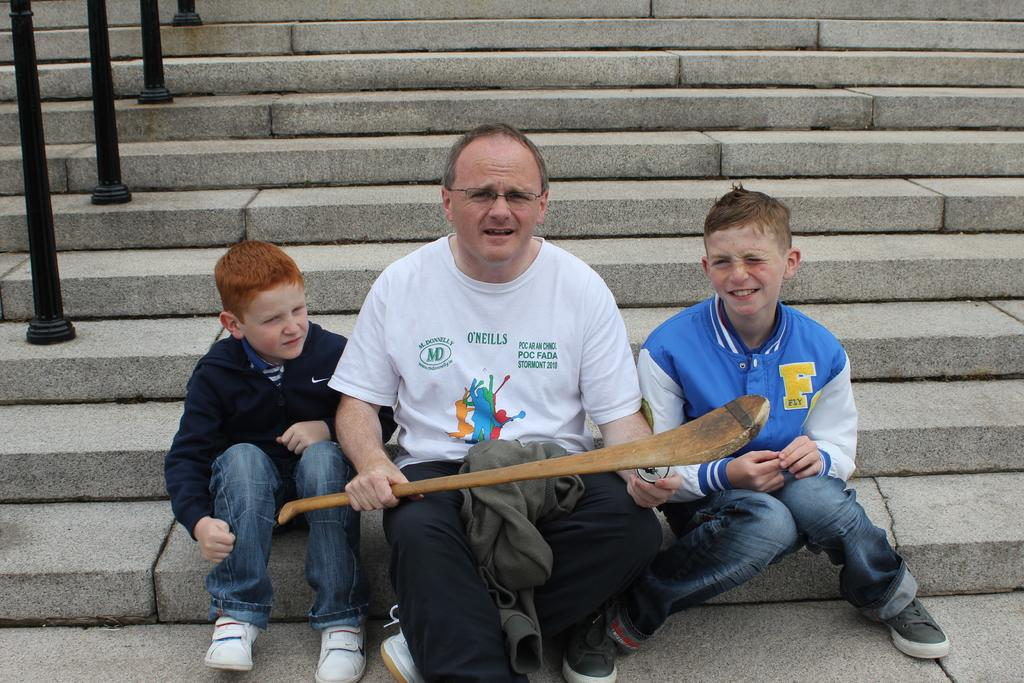How many people are sitting on the steps in the image? There are three persons sitting on the steps in the image. What is one of the persons holding in their hand? One person is holding a stick in their hand. What architectural feature can be seen in the left top of the image? There are pillars visible in the left top of the image. When was the image taken, based on the lighting? The image was taken during the day, as there is sufficient natural light. What type of tent can be seen in the background of the image? There is no tent present in the image; it features three persons sitting on the steps and pillars in the background. 